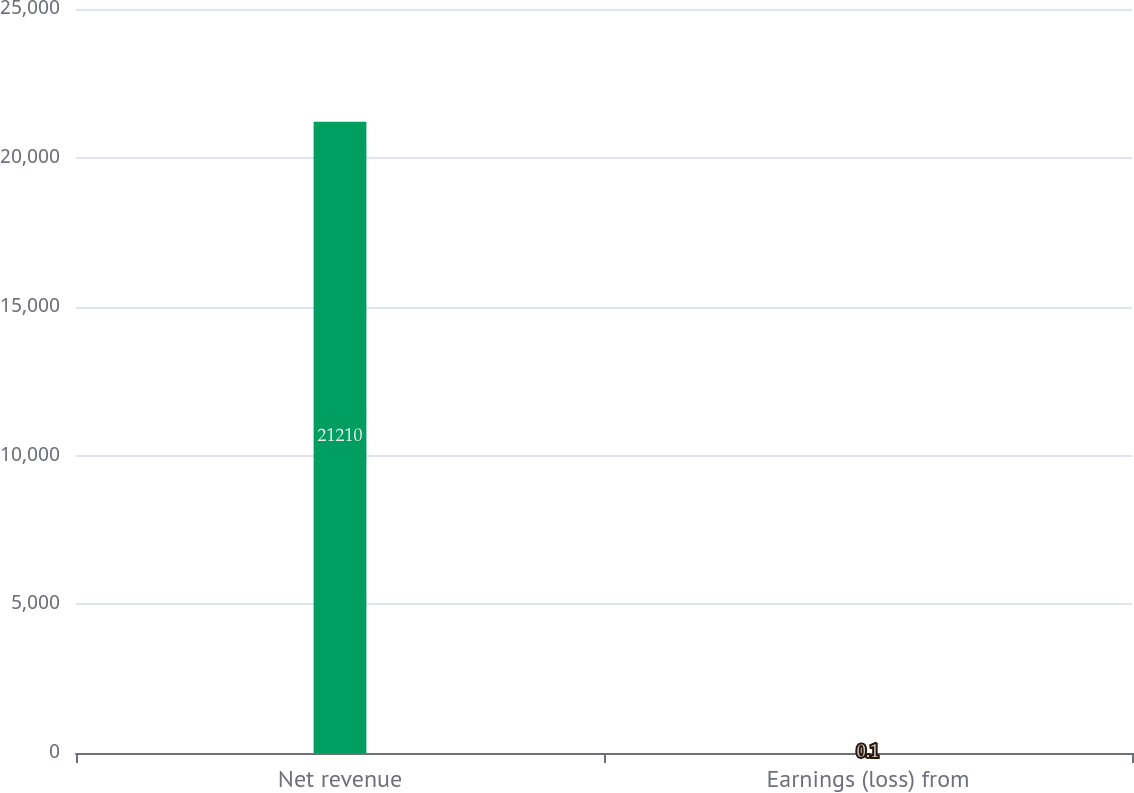Convert chart to OTSL. <chart><loc_0><loc_0><loc_500><loc_500><bar_chart><fcel>Net revenue<fcel>Earnings (loss) from<nl><fcel>21210<fcel>0.1<nl></chart> 